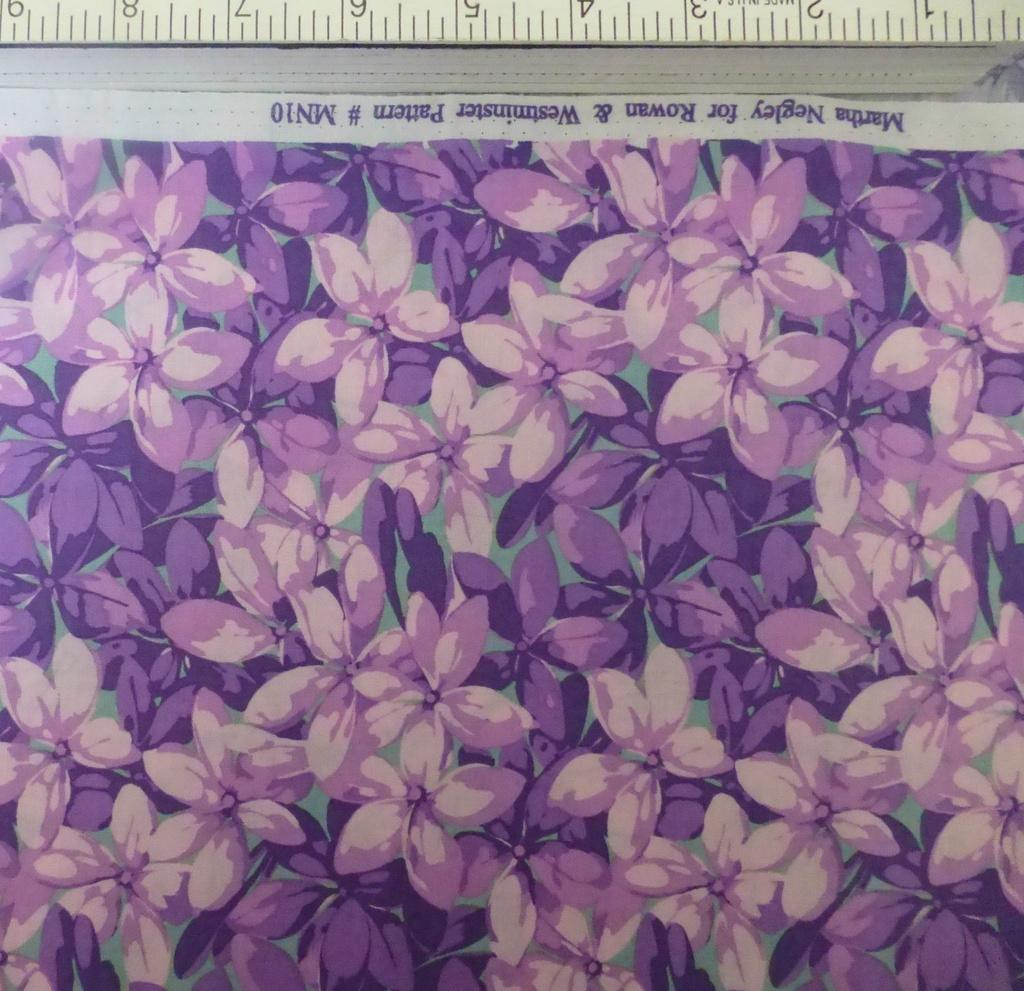Provide a one-sentence caption for the provided image. a purple print of flowers by Martha Wegley. 